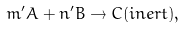<formula> <loc_0><loc_0><loc_500><loc_500>m ^ { \prime } A + n ^ { \prime } B \rightarrow C ( i n e r t ) ,</formula> 